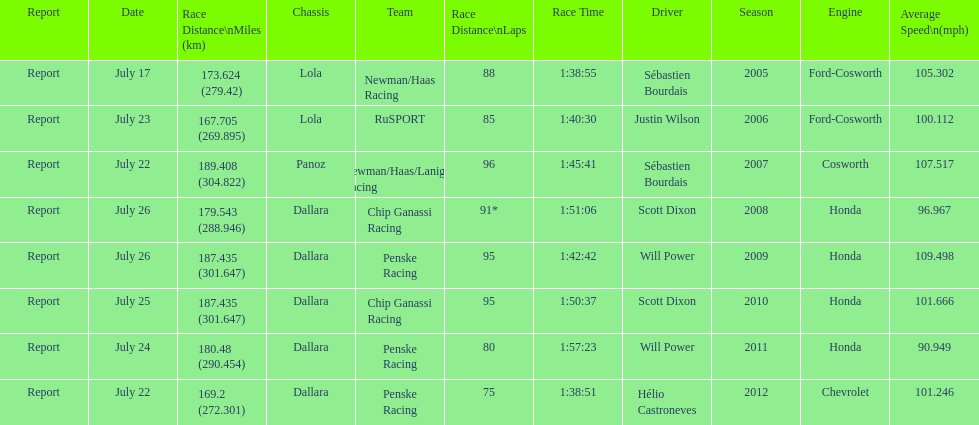Was the average speed in the year 2011 of the indycar series above or below the average speed of the year before? Below. 